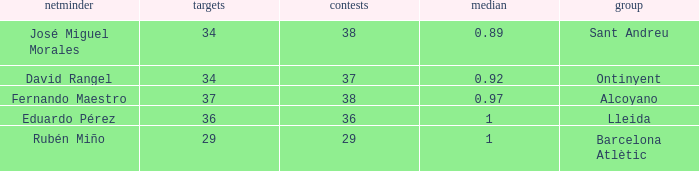What is the sum of Goals, when Matches is less than 29? None. 